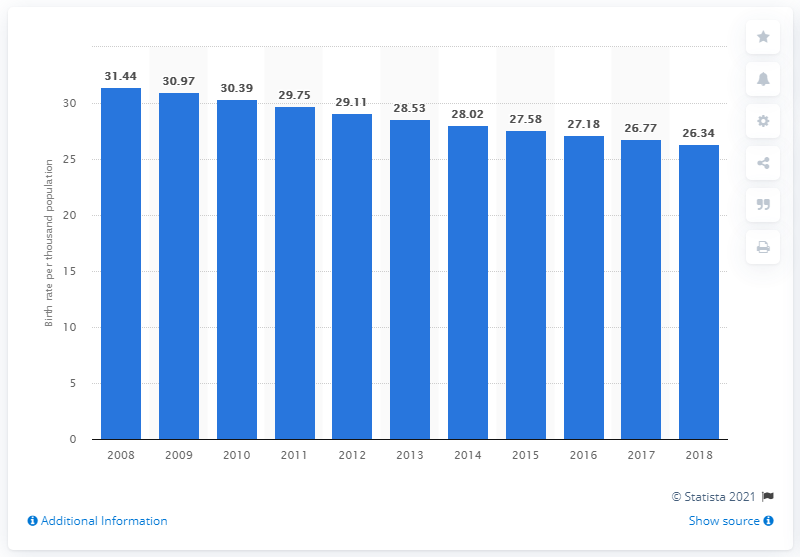List a handful of essential elements in this visual. In 2018, the crude birth rate in the Kingdom of Eswatini was 26.34. The Kingdom of Eswatini was formerly known as Swaziland until 2008. 